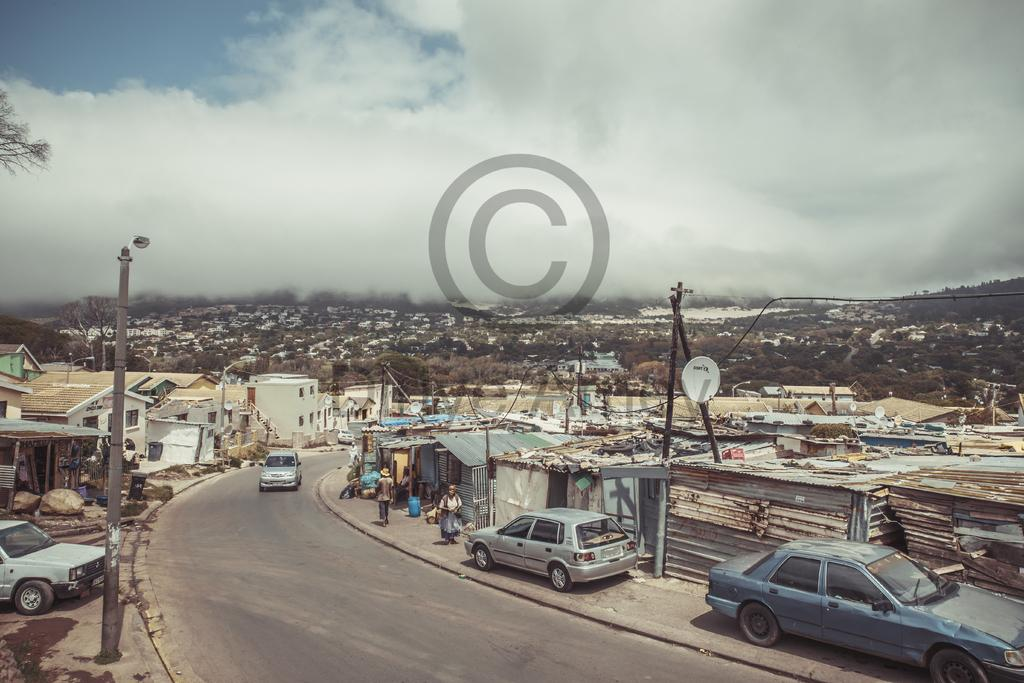What is located in the center of the image? There is a watermark in the center of the image. What types of vehicles can be seen in the image? The image contains vehicles, but the specific types are not mentioned. What can be seen in the background of the image? The background of the image includes the sky, clouds, buildings, trees, poles, and people. How many different types of objects are present in the background of the image? There are at least nine different types of objects present in the background of the image, including the sky, clouds, buildings, trees, poles, people, and other unspecified objects. What color is the balloon that is floating above the trees in the image? There is no balloon present in the image; it only contains a watermark, vehicles, the sky, clouds, buildings, trees, poles, and people. 